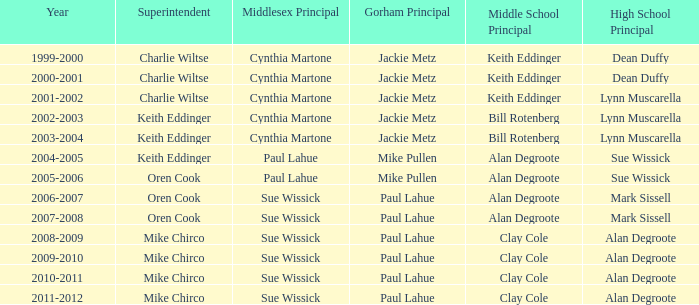Who were the superintendent(s) when the middle school principal was alan degroote, the gorham principal was paul lahue, and the year was 2006-2007? Oren Cook. 